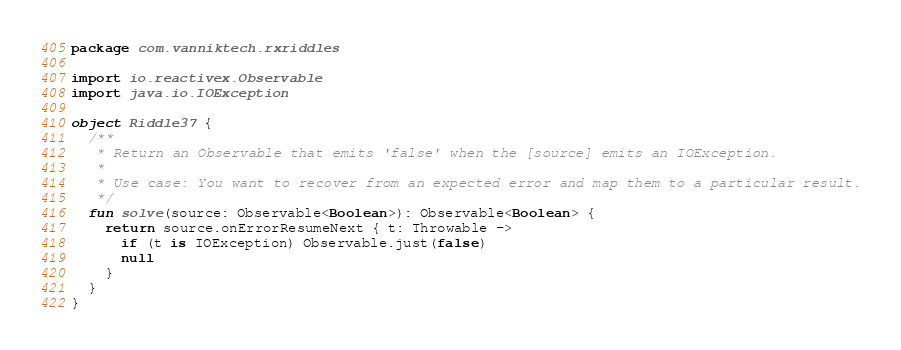<code> <loc_0><loc_0><loc_500><loc_500><_Kotlin_>package com.vanniktech.rxriddles

import io.reactivex.Observable
import java.io.IOException

object Riddle37 {
  /**
   * Return an Observable that emits 'false' when the [source] emits an IOException.
   *
   * Use case: You want to recover from an expected error and map them to a particular result.
   */
  fun solve(source: Observable<Boolean>): Observable<Boolean> {
    return source.onErrorResumeNext { t: Throwable ->
      if (t is IOException) Observable.just(false)
      null
    }
  }
}
</code> 